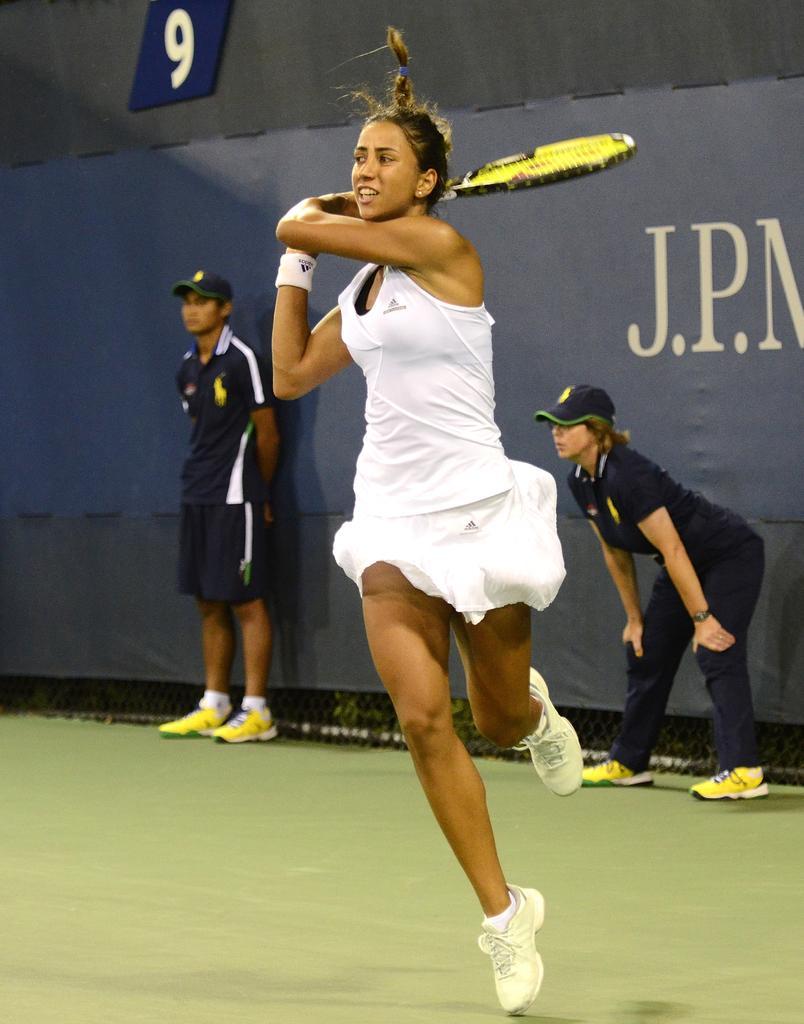Could you give a brief overview of what you see in this image? The image is taken inside a playground. In the image there is a woman wearing a white color dress and holding a tennis racket. On right side there is another woman who is standing, in left side there is a man wearing a hat and standing. In background there is a blue color hoarding at bottom the land is green color. 